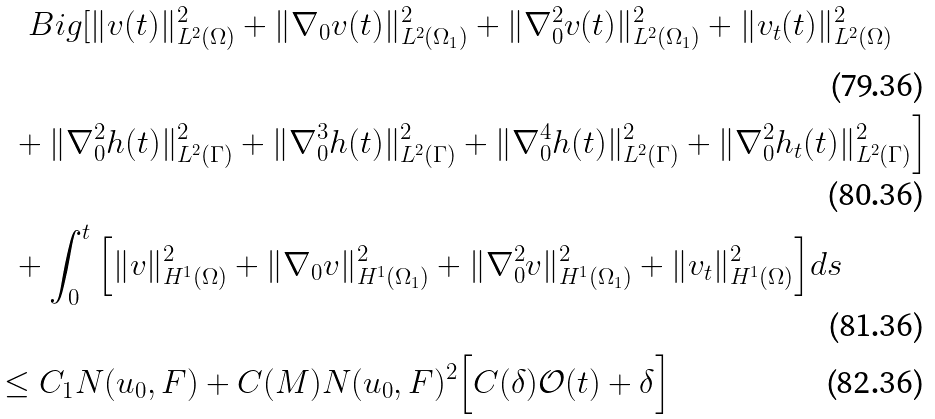<formula> <loc_0><loc_0><loc_500><loc_500>& \quad B i g [ \| v ( t ) \| ^ { 2 } _ { L ^ { 2 } ( \Omega ) } + \| \nabla _ { 0 } v ( t ) \| ^ { 2 } _ { L ^ { 2 } ( \Omega _ { 1 } ) } + \| \nabla _ { 0 } ^ { 2 } v ( t ) \| ^ { 2 } _ { L ^ { 2 } ( \Omega _ { 1 } ) } + \| v _ { t } ( t ) \| ^ { 2 } _ { L ^ { 2 } ( \Omega ) } \\ & \ \ + \| \nabla _ { 0 } ^ { 2 } h ( t ) \| ^ { 2 } _ { L ^ { 2 } ( \Gamma ) } + \| \nabla _ { 0 } ^ { 3 } h ( t ) \| ^ { 2 } _ { L ^ { 2 } ( \Gamma ) } + \| \nabla _ { 0 } ^ { 4 } h ( t ) \| ^ { 2 } _ { L ^ { 2 } ( \Gamma ) } + \| \nabla _ { 0 } ^ { 2 } h _ { t } ( t ) \| ^ { 2 } _ { L ^ { 2 } ( \Gamma ) } \Big ] \\ & \ \ + \int _ { 0 } ^ { t } \Big [ \| v \| ^ { 2 } _ { H ^ { 1 } ( \Omega ) } + \| \nabla _ { 0 } v \| ^ { 2 } _ { H ^ { 1 } ( \Omega _ { 1 } ) } + \| \nabla _ { 0 } ^ { 2 } v \| ^ { 2 } _ { H ^ { 1 } ( \Omega _ { 1 } ) } + \| v _ { t } \| ^ { 2 } _ { H ^ { 1 } ( \Omega ) } \Big ] d s \\ & \leq C _ { 1 } N ( u _ { 0 } , F ) + C ( M ) N ( u _ { 0 } , F ) ^ { 2 } \Big [ C ( \delta ) { \mathcal { O } } ( t ) + \delta \Big ]</formula> 